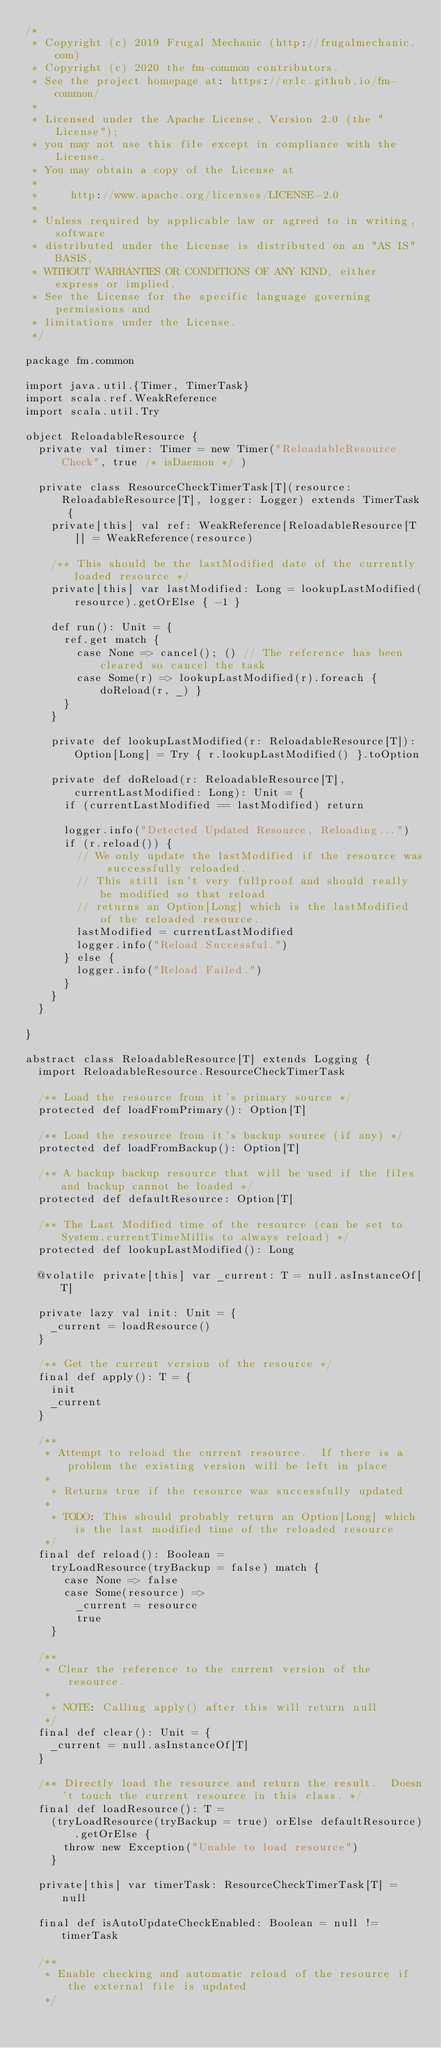<code> <loc_0><loc_0><loc_500><loc_500><_Scala_>/*
 * Copyright (c) 2019 Frugal Mechanic (http://frugalmechanic.com)
 * Copyright (c) 2020 the fm-common contributors.
 * See the project homepage at: https://er1c.github.io/fm-common/
 *
 * Licensed under the Apache License, Version 2.0 (the "License");
 * you may not use this file except in compliance with the License.
 * You may obtain a copy of the License at
 *
 *     http://www.apache.org/licenses/LICENSE-2.0
 *
 * Unless required by applicable law or agreed to in writing, software
 * distributed under the License is distributed on an "AS IS" BASIS,
 * WITHOUT WARRANTIES OR CONDITIONS OF ANY KIND, either express or implied.
 * See the License for the specific language governing permissions and
 * limitations under the License.
 */

package fm.common

import java.util.{Timer, TimerTask}
import scala.ref.WeakReference
import scala.util.Try

object ReloadableResource {
  private val timer: Timer = new Timer("ReloadableResource Check", true /* isDaemon */ )

  private class ResourceCheckTimerTask[T](resource: ReloadableResource[T], logger: Logger) extends TimerTask {
    private[this] val ref: WeakReference[ReloadableResource[T]] = WeakReference(resource)

    /** This should be the lastModified date of the currently loaded resource */
    private[this] var lastModified: Long = lookupLastModified(resource).getOrElse { -1 }

    def run(): Unit = {
      ref.get match {
        case None => cancel(); () // The reference has been cleared so cancel the task
        case Some(r) => lookupLastModified(r).foreach { doReload(r, _) }
      }
    }

    private def lookupLastModified(r: ReloadableResource[T]): Option[Long] = Try { r.lookupLastModified() }.toOption

    private def doReload(r: ReloadableResource[T], currentLastModified: Long): Unit = {
      if (currentLastModified == lastModified) return

      logger.info("Detected Updated Resource, Reloading...")
      if (r.reload()) {
        // We only update the lastModified if the resource was successfully reloaded.
        // This still isn't very fullproof and should really be modified so that reload
        // returns an Option[Long] which is the lastModified of the reloaded resource.
        lastModified = currentLastModified
        logger.info("Reload Successful.")
      } else {
        logger.info("Reload Failed.")
      }
    }
  }

}

abstract class ReloadableResource[T] extends Logging {
  import ReloadableResource.ResourceCheckTimerTask

  /** Load the resource from it's primary source */
  protected def loadFromPrimary(): Option[T]

  /** Load the resource from it's backup source (if any) */
  protected def loadFromBackup(): Option[T]

  /** A backup backup resource that will be used if the files and backup cannot be loaded */
  protected def defaultResource: Option[T]

  /** The Last Modified time of the resource (can be set to System.currentTimeMillis to always reload) */
  protected def lookupLastModified(): Long

  @volatile private[this] var _current: T = null.asInstanceOf[T]

  private lazy val init: Unit = {
    _current = loadResource()
  }

  /** Get the current version of the resource */
  final def apply(): T = {
    init
    _current
  }

  /**
   * Attempt to reload the current resource.  If there is a problem the existing version will be left in place
   *
    * Returns true if the resource was successfully updated
   *
    * TODO: This should probably return an Option[Long] which is the last modified time of the reloaded resource
   */
  final def reload(): Boolean =
    tryLoadResource(tryBackup = false) match {
      case None => false
      case Some(resource) =>
        _current = resource
        true
    }

  /**
   * Clear the reference to the current version of the resource.
   *
    * NOTE: Calling apply() after this will return null
   */
  final def clear(): Unit = {
    _current = null.asInstanceOf[T]
  }

  /** Directly load the resource and return the result.  Doesn't touch the current resource in this class. */
  final def loadResource(): T =
    (tryLoadResource(tryBackup = true) orElse defaultResource).getOrElse {
      throw new Exception("Unable to load resource")
    }

  private[this] var timerTask: ResourceCheckTimerTask[T] = null

  final def isAutoUpdateCheckEnabled: Boolean = null != timerTask

  /**
   * Enable checking and automatic reload of the resource if the external file is updated
   */</code> 